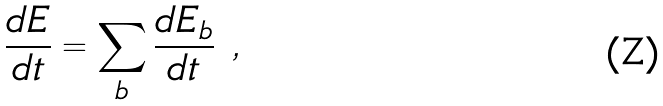Convert formula to latex. <formula><loc_0><loc_0><loc_500><loc_500>\frac { d E } { d t } = \sum _ { b } \frac { d E _ { b } } { d t } \ ,</formula> 